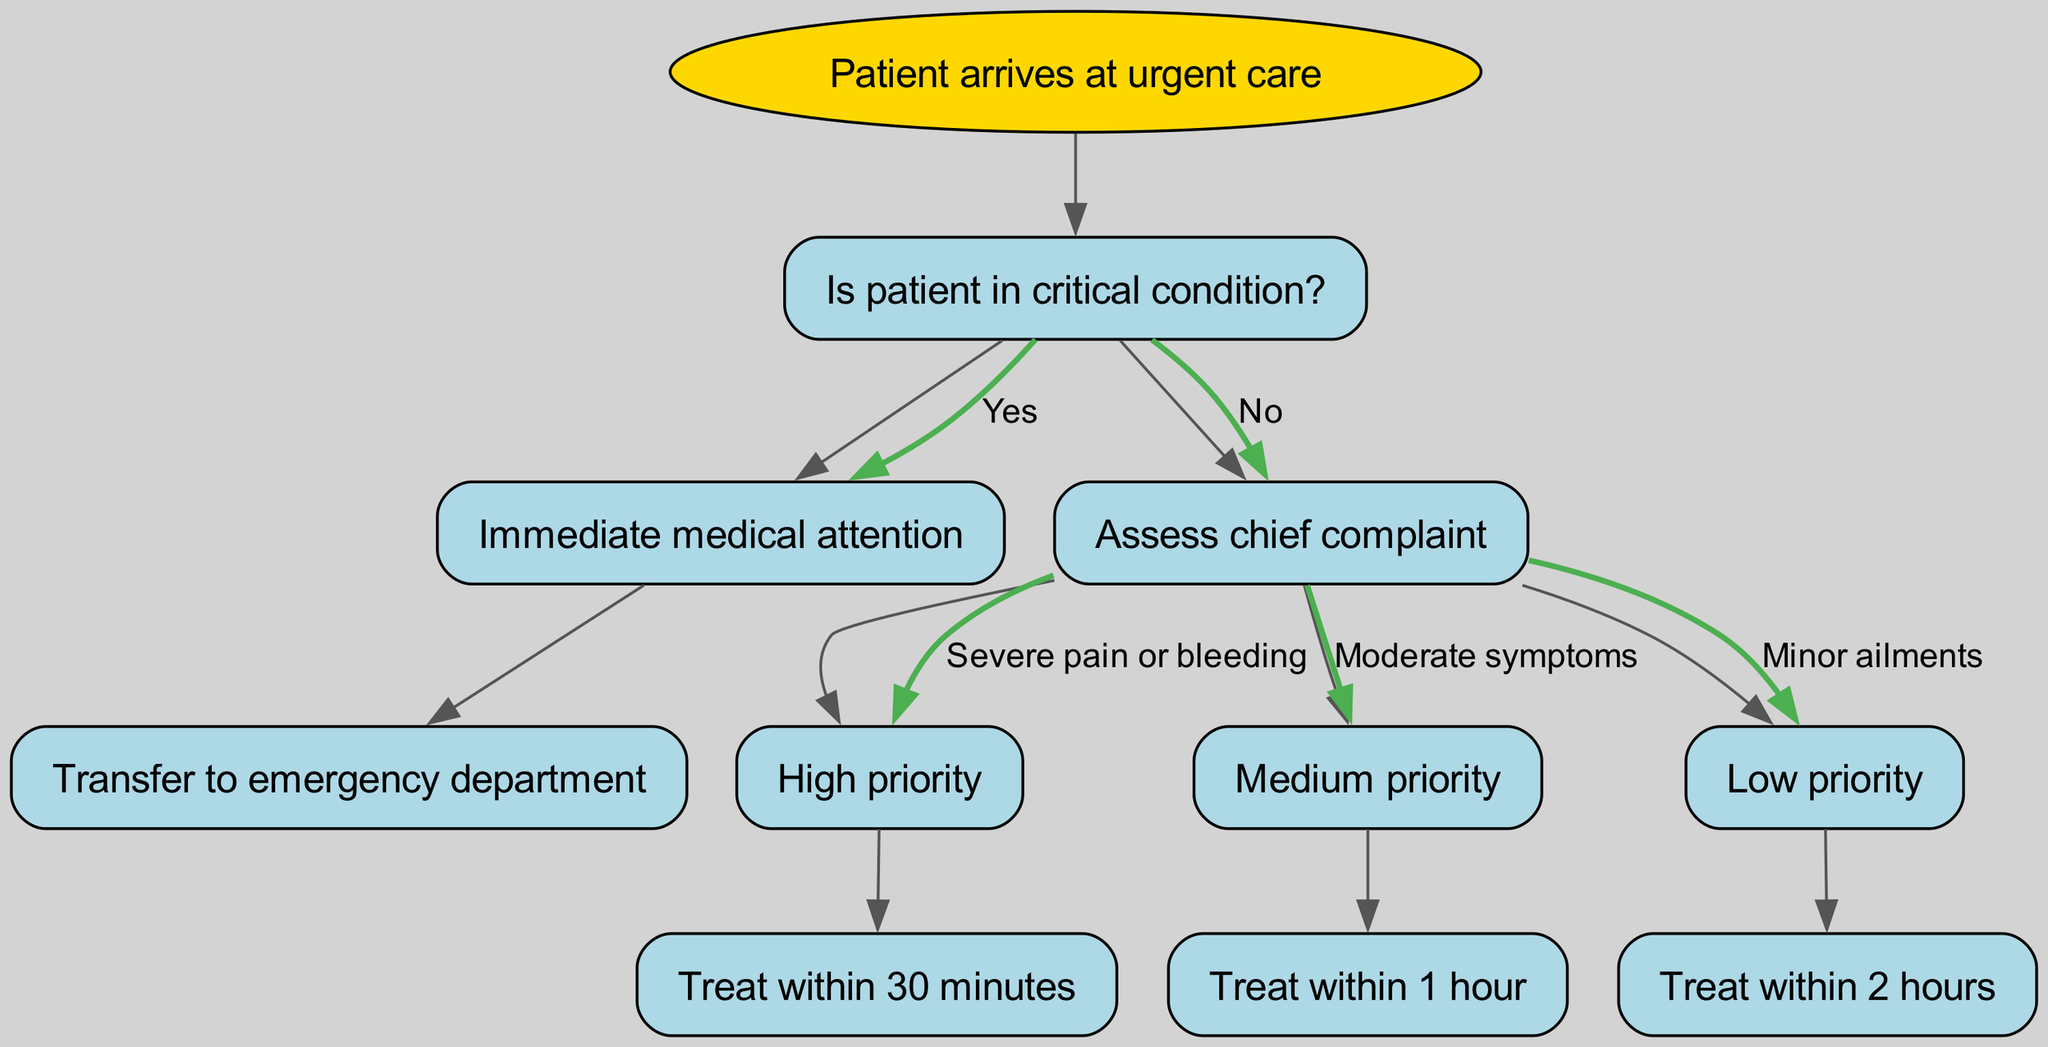What is the root node of the diagram? The root node is labeled "Patient arrives at urgent care", indicating the starting point of the decision-making process in the diagram.
Answer: Patient arrives at urgent care How many children does the root node have? The root node has two children: "Is patient in critical condition?" and "Assess chief complaint". Therefore, there are a total of 2 children nodes linked from the root.
Answer: 2 What happens if the patient is assessed as having high priority? If the patient is classified as having high priority, the next action is to "Treat within 30 minutes", indicating a swift response to urgent conditions.
Answer: Treat within 30 minutes What is the treatment time associated with low priority? Low priority is associated with a treatment time of "Treat within 2 hours", which indicates that the conditions are not as urgent as higher priority cases.
Answer: Treat within 2 hours What two conditions would lead to "Immediate medical attention"? If the patient is in "critical condition", they receive "Immediate medical attention", which requires transferring to an emergency department if necessary.
Answer: Immediate medical attention What is the action taken for a patient with moderate symptoms? For a patient with moderate symptoms, the action is to "Treat within 1 hour", which reflects a medium urgency level according to the triage process.
Answer: Treat within 1 hour What is the relationship between "Assess chief complaint" and "High priority"? "Assess chief complaint" leads to determining the priority level of the patient's condition, and if classified as high priority, it specifically directs to "Treat within 30 minutes". Thus, "High priority" is a child node of "Assess chief complaint".
Answer: Treat within 30 minutes What label is used if the patient is not in critical condition? If the patient is not in critical condition, the next step is to "Assess chief complaint", demonstrating a process to evaluate the patient's symptoms.
Answer: Assess chief complaint What is the base level of urgency for minor ailments? The base level of urgency for minor ailments is classified as "Low priority", requiring treatment to occur within a set timeframe.
Answer: Low priority 